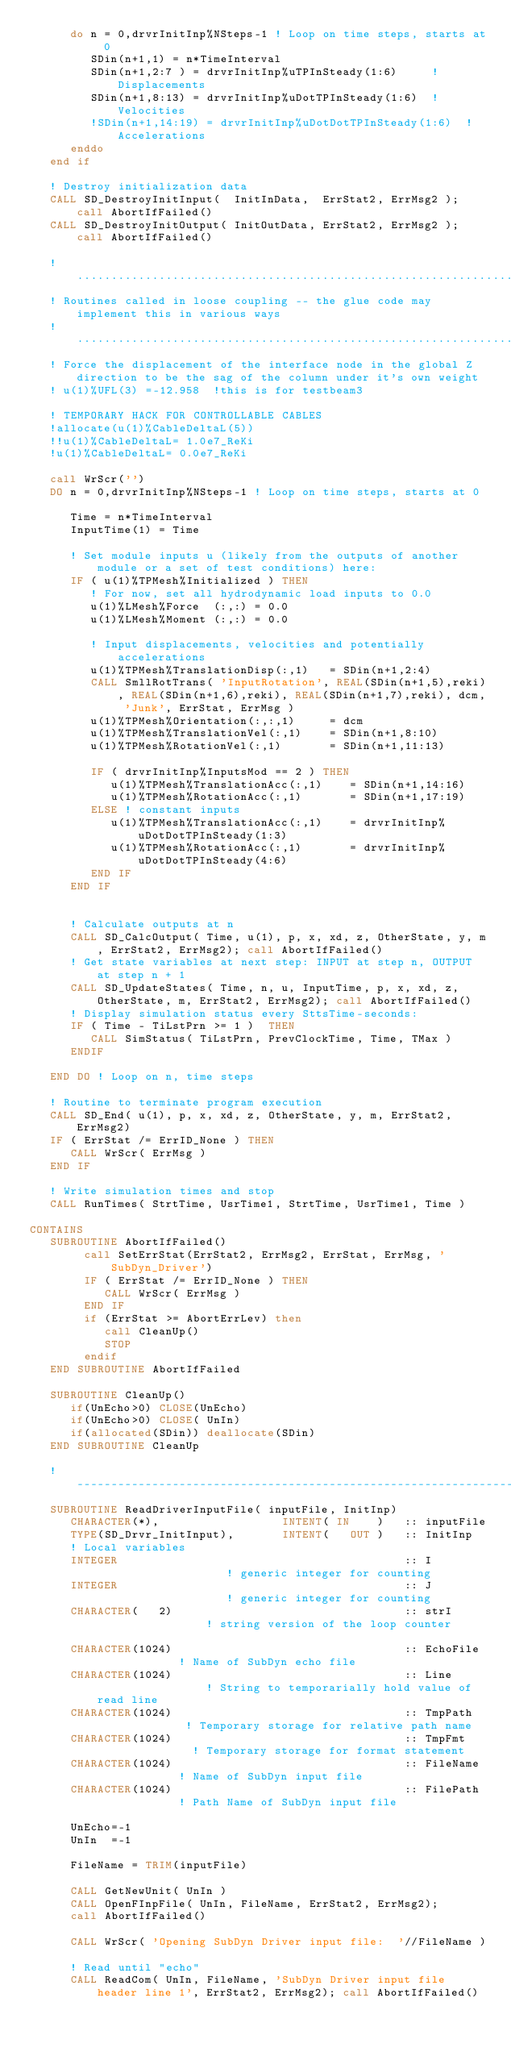<code> <loc_0><loc_0><loc_500><loc_500><_FORTRAN_>      do n = 0,drvrInitInp%NSteps-1 ! Loop on time steps, starts at 0
         SDin(n+1,1) = n*TimeInterval
         SDin(n+1,2:7 ) = drvrInitInp%uTPInSteady(1:6)     ! Displacements
         SDin(n+1,8:13) = drvrInitInp%uDotTPInSteady(1:6)  ! Velocities
         !SDin(n+1,14:19) = drvrInitInp%uDotDotTPInSteady(1:6)  ! Accelerations
      enddo
   end if 
  
   ! Destroy initialization data
   CALL SD_DestroyInitInput(  InitInData,  ErrStat2, ErrMsg2 ); call AbortIfFailed()
   CALL SD_DestroyInitOutput( InitOutData, ErrStat2, ErrMsg2 ); call AbortIfFailed()

   !...............................................................................................................................
   ! Routines called in loose coupling -- the glue code may implement this in various ways
   !...............................................................................................................................
   ! Force the displacement of the interface node in the global Z direction to be the sag of the column under it's own weight
   ! u(1)%UFL(3) =-12.958  !this is for testbeam3

   ! TEMPORARY HACK FOR CONTROLLABLE CABLES
   !allocate(u(1)%CableDeltaL(5))
   !!u(1)%CableDeltaL= 1.0e7_ReKi
   !u(1)%CableDeltaL= 0.0e7_ReKi

   call WrScr('')
   DO n = 0,drvrInitInp%NSteps-1 ! Loop on time steps, starts at 0

      Time = n*TimeInterval
      InputTime(1) = Time

      ! Set module inputs u (likely from the outputs of another module or a set of test conditions) here:
      IF ( u(1)%TPMesh%Initialized ) THEN 
         ! For now, set all hydrodynamic load inputs to 0.0
         u(1)%LMesh%Force  (:,:) = 0.0
         u(1)%LMesh%Moment (:,:) = 0.0
         
         ! Input displacements, velocities and potentially accelerations
         u(1)%TPMesh%TranslationDisp(:,1)   = SDin(n+1,2:4) 
         CALL SmllRotTrans( 'InputRotation', REAL(SDin(n+1,5),reki), REAL(SDin(n+1,6),reki), REAL(SDin(n+1,7),reki), dcm, 'Junk', ErrStat, ErrMsg )            
         u(1)%TPMesh%Orientation(:,:,1)     = dcm 
         u(1)%TPMesh%TranslationVel(:,1)    = SDin(n+1,8:10)  
         u(1)%TPMesh%RotationVel(:,1)       = SDin(n+1,11:13) 

         IF ( drvrInitInp%InputsMod == 2 ) THEN
            u(1)%TPMesh%TranslationAcc(:,1)    = SDin(n+1,14:16) 
            u(1)%TPMesh%RotationAcc(:,1)       = SDin(n+1,17:19)
         ELSE ! constant inputs
            u(1)%TPMesh%TranslationAcc(:,1)    = drvrInitInp%uDotDotTPInSteady(1:3)  
            u(1)%TPMesh%RotationAcc(:,1)       = drvrInitInp%uDotDotTPInSteady(4:6) 
         END IF
      END IF   


      ! Calculate outputs at n
      CALL SD_CalcOutput( Time, u(1), p, x, xd, z, OtherState, y, m, ErrStat2, ErrMsg2); call AbortIfFailed()
      ! Get state variables at next step: INPUT at step n, OUTPUT at step n + 1
      CALL SD_UpdateStates( Time, n, u, InputTime, p, x, xd, z, OtherState, m, ErrStat2, ErrMsg2); call AbortIfFailed()
      ! Display simulation status every SttsTime-seconds:
      IF ( Time - TiLstPrn >= 1 )  THEN
         CALL SimStatus( TiLstPrn, PrevClockTime, Time, TMax )
      ENDIF   

   END DO ! Loop on n, time steps

   ! Routine to terminate program execution
   CALL SD_End( u(1), p, x, xd, z, OtherState, y, m, ErrStat2, ErrMsg2)
   IF ( ErrStat /= ErrID_None ) THEN
      CALL WrScr( ErrMsg )
   END IF

   ! Write simulation times and stop
   CALL RunTimes( StrtTime, UsrTime1, StrtTime, UsrTime1, Time )
   
CONTAINS
   SUBROUTINE AbortIfFailed()
        call SetErrStat(ErrStat2, ErrMsg2, ErrStat, ErrMsg, 'SubDyn_Driver') 
        IF ( ErrStat /= ErrID_None ) THEN
           CALL WrScr( ErrMsg )
        END IF
        if (ErrStat >= AbortErrLev) then
           call CleanUp()
           STOP
        endif
   END SUBROUTINE AbortIfFailed

   SUBROUTINE CleanUp()
      if(UnEcho>0) CLOSE(UnEcho)
      if(UnEcho>0) CLOSE( UnIn)
      if(allocated(SDin)) deallocate(SDin)
   END SUBROUTINE CleanUp

   !-------------------------------------------------------------------------------------------------------------------------------
   SUBROUTINE ReadDriverInputFile( inputFile, InitInp)
      CHARACTER(*),                  INTENT( IN    )   :: inputFile
      TYPE(SD_Drvr_InitInput),       INTENT(   OUT )   :: InitInp
      ! Local variables  
      INTEGER                                          :: I                    ! generic integer for counting
      INTEGER                                          :: J                    ! generic integer for counting
      CHARACTER(   2)                                  :: strI                 ! string version of the loop counter

      CHARACTER(1024)                                  :: EchoFile             ! Name of SubDyn echo file  
      CHARACTER(1024)                                  :: Line                 ! String to temporarially hold value of read line   
      CHARACTER(1024)                                  :: TmpPath              ! Temporary storage for relative path name
      CHARACTER(1024)                                  :: TmpFmt               ! Temporary storage for format statement
      CHARACTER(1024)                                  :: FileName             ! Name of SubDyn input file  
      CHARACTER(1024)                                  :: FilePath             ! Path Name of SubDyn input file  
   
      UnEcho=-1
      UnIn  =-1
   
      FileName = TRIM(inputFile)
   
      CALL GetNewUnit( UnIn )   
      CALL OpenFInpFile( UnIn, FileName, ErrStat2, ErrMsg2);
      call AbortIfFailed()
   
      CALL WrScr( 'Opening SubDyn Driver input file:  '//FileName )
      
      ! Read until "echo"
      CALL ReadCom( UnIn, FileName, 'SubDyn Driver input file header line 1', ErrStat2, ErrMsg2); call AbortIfFailed()</code> 